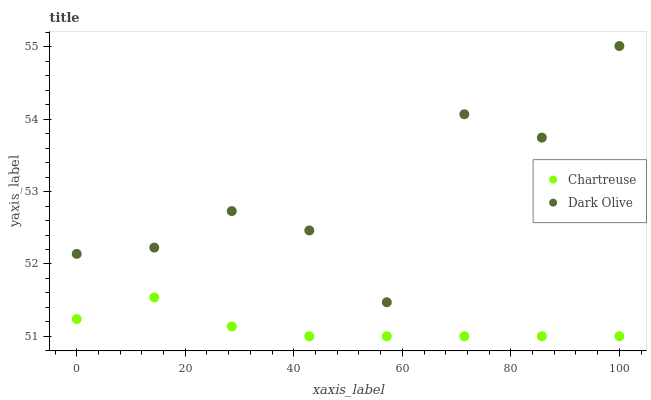Does Chartreuse have the minimum area under the curve?
Answer yes or no. Yes. Does Dark Olive have the maximum area under the curve?
Answer yes or no. Yes. Does Dark Olive have the minimum area under the curve?
Answer yes or no. No. Is Chartreuse the smoothest?
Answer yes or no. Yes. Is Dark Olive the roughest?
Answer yes or no. Yes. Is Dark Olive the smoothest?
Answer yes or no. No. Does Chartreuse have the lowest value?
Answer yes or no. Yes. Does Dark Olive have the lowest value?
Answer yes or no. No. Does Dark Olive have the highest value?
Answer yes or no. Yes. Is Chartreuse less than Dark Olive?
Answer yes or no. Yes. Is Dark Olive greater than Chartreuse?
Answer yes or no. Yes. Does Chartreuse intersect Dark Olive?
Answer yes or no. No. 